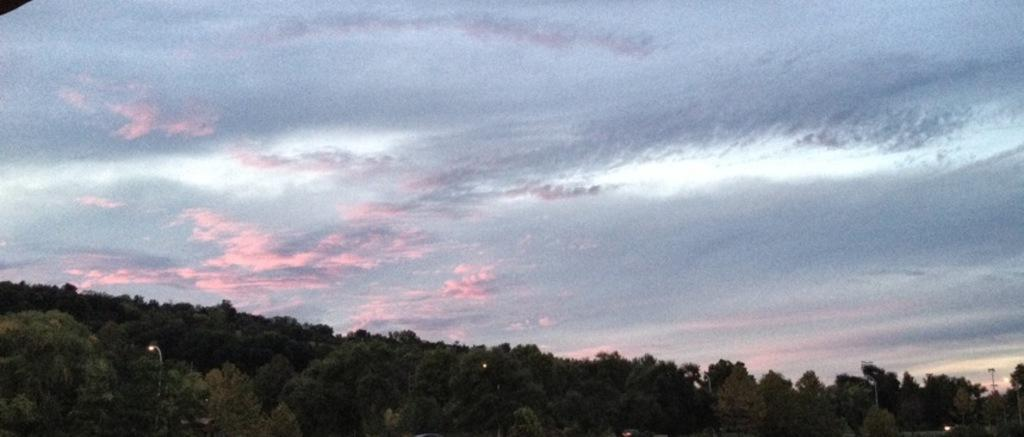What type of vegetation can be seen in the image? There are trees in the image. What else is visible in the image besides the trees? There are lights and the sky visible in the image. What can be seen in the sky? There are clouds in the sky. What type of cheese is being used to create the lights in the image? There is no cheese present in the image, and the lights are not made of cheese. 